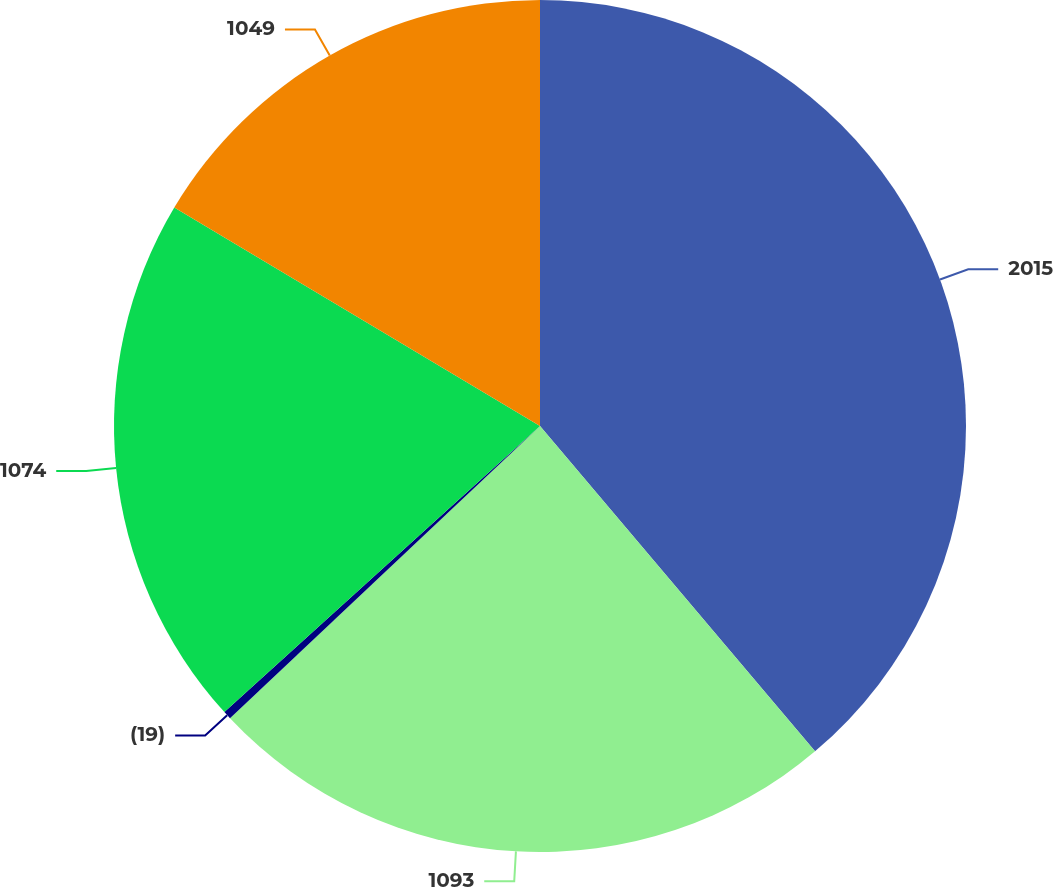<chart> <loc_0><loc_0><loc_500><loc_500><pie_chart><fcel>2015<fcel>1093<fcel>(19)<fcel>1074<fcel>1049<nl><fcel>38.83%<fcel>24.14%<fcel>0.31%<fcel>20.29%<fcel>16.43%<nl></chart> 